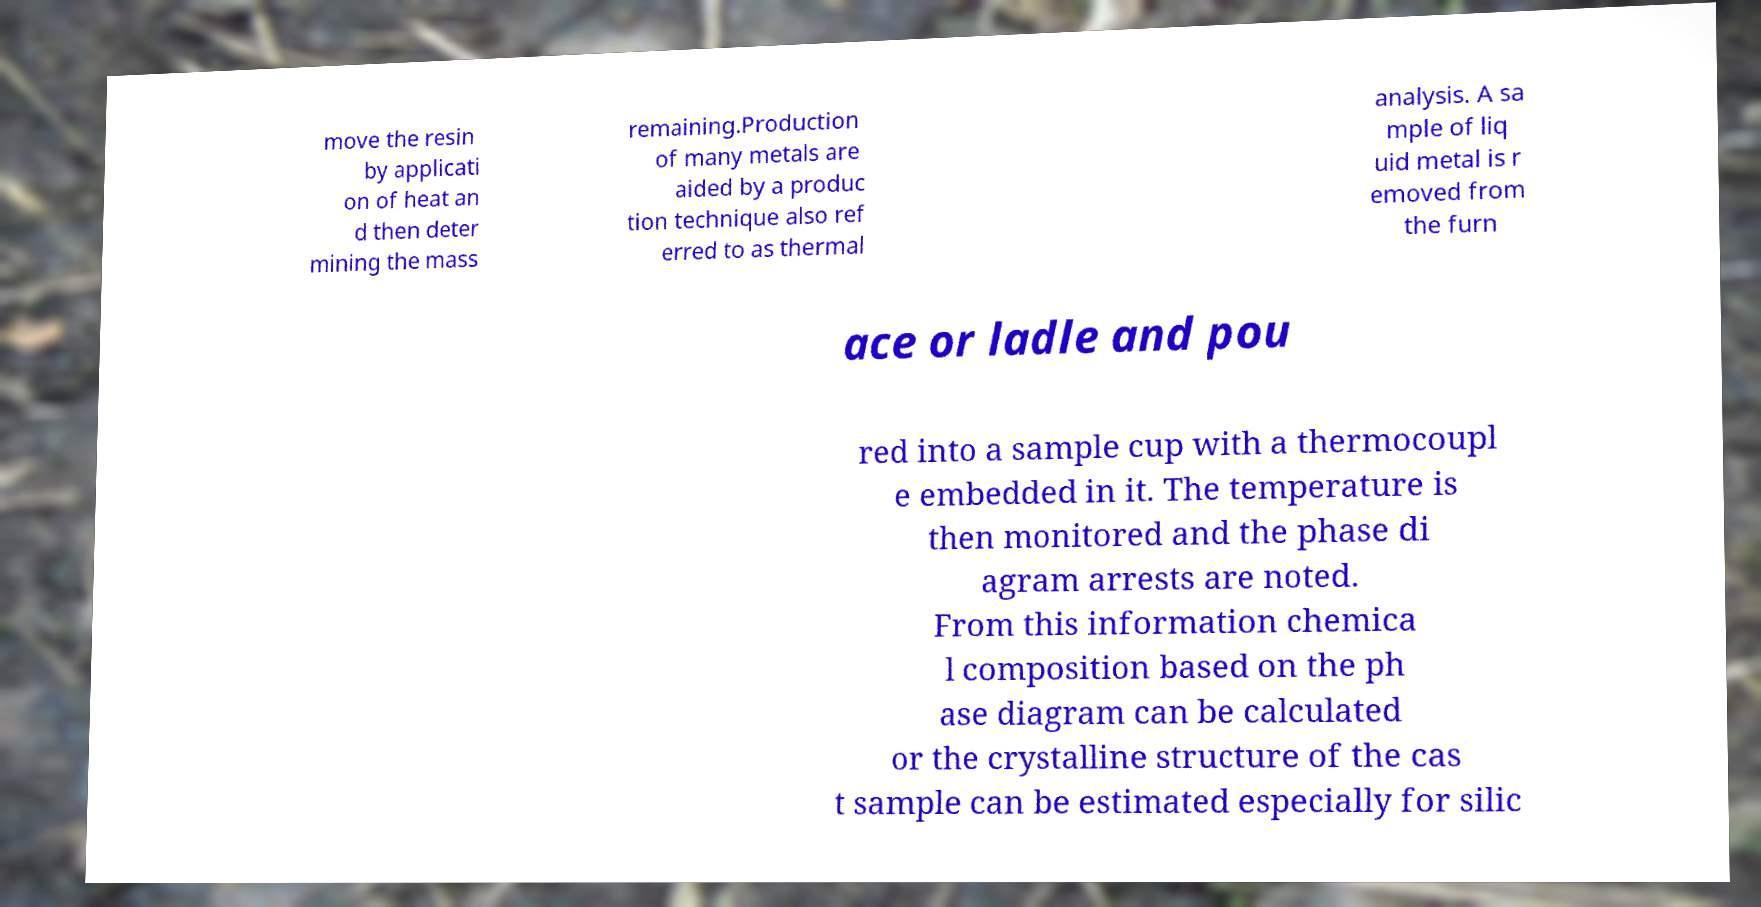I need the written content from this picture converted into text. Can you do that? move the resin by applicati on of heat an d then deter mining the mass remaining.Production of many metals are aided by a produc tion technique also ref erred to as thermal analysis. A sa mple of liq uid metal is r emoved from the furn ace or ladle and pou red into a sample cup with a thermocoupl e embedded in it. The temperature is then monitored and the phase di agram arrests are noted. From this information chemica l composition based on the ph ase diagram can be calculated or the crystalline structure of the cas t sample can be estimated especially for silic 